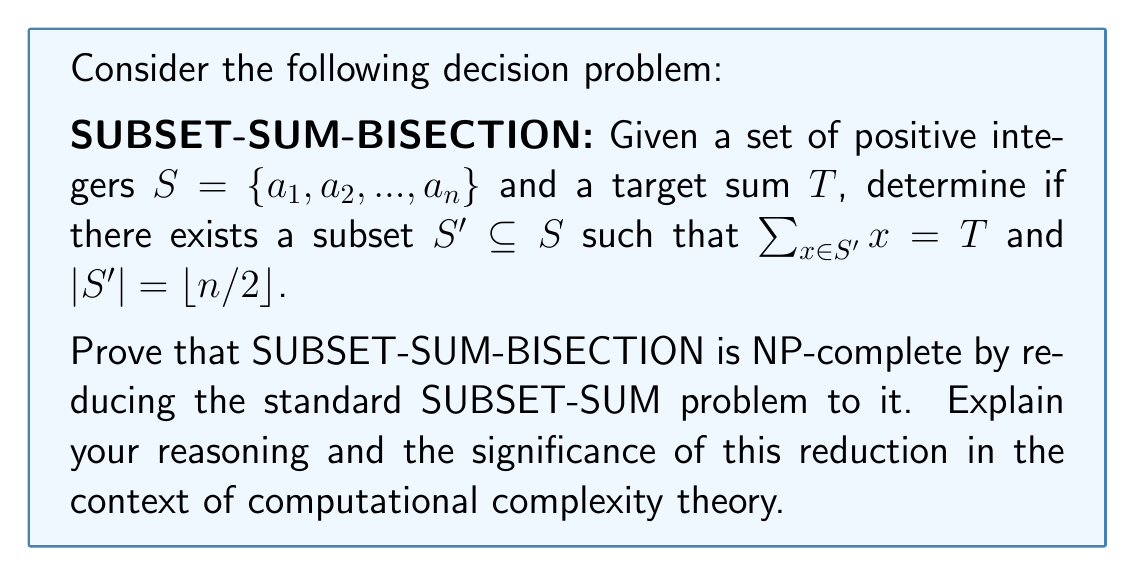Give your solution to this math problem. To prove that SUBSET-SUM-BISECTION is NP-complete, we need to show two things:
1. It is in NP
2. It is NP-hard (by reducing a known NP-complete problem to it)

Step 1: Showing SUBSET-SUM-BISECTION is in NP
This is straightforward. Given a solution (a subset $S'$), we can verify in polynomial time that:
a) $|S'| = \lfloor n/2 \rfloor$
b) $\sum_{x \in S'} x = T$

Step 2: Reducing SUBSET-SUM to SUBSET-SUM-BISECTION
We know SUBSET-SUM is NP-complete. Let's reduce it to SUBSET-SUM-BISECTION.

Given a SUBSET-SUM instance $(S, T)$, where $S = \{a_1, ..., a_n\}$ and $T$ is the target sum, we construct a SUBSET-SUM-BISECTION instance $(S', T')$ as follows:

1. If $n$ is odd, add a 0 to $S$ to make it even.
2. Let $M = 1 + \sum_{i=1}^n a_i$
3. $S' = S \cup \{M, M, ..., M\}$ (add $n$ copies of $M$)
4. $T' = T + nM/2$

This reduction is polynomial-time computable.

Claim: The original SUBSET-SUM instance has a solution if and only if the new SUBSET-SUM-BISECTION instance has a solution.

Proof:
($\Rightarrow$) If SUBSET-SUM has a solution, let $k$ be the size of this solution. Choose $k$ elements from the original set and $n-k$ copies of $M$ from the added elements. This subset has size $n = |S'|/2$ and sum $T + (n-k)M = T'$.

($\Leftarrow$) If SUBSET-SUM-BISECTION has a solution, it must include exactly $n/2$ elements. Due to the choice of $M$, it's impossible to reach $T'$ without using exactly $n/2$ copies of $M$. The remaining elements must sum to $T$, forming a solution to the original SUBSET-SUM problem.

This reduction demonstrates that SUBSET-SUM-BISECTION is at least as hard as SUBSET-SUM. Since SUBSET-SUM is NP-complete, this proves that SUBSET-SUM-BISECTION is NP-hard.

Combining steps 1 and 2, we conclude that SUBSET-SUM-BISECTION is NP-complete.

The significance of this reduction lies in its demonstration of how we can use known NP-complete problems to prove the NP-completeness of new problems. This technique, known as reduction, is fundamental in computational complexity theory. It allows us to establish relationships between problems and build a hierarchy of computational difficulty. By showing that a problem is at least as hard as a known NP-complete problem, we prove its NP-hardness, which is a crucial step in establishing NP-completeness.
Answer: SUBSET-SUM-BISECTION is NP-complete. The proof involves showing it is in NP and reducing the known NP-complete problem SUBSET-SUM to it. The reduction transforms a SUBSET-SUM instance $(S, T)$ to a SUBSET-SUM-BISECTION instance $(S', T')$ by adding $n$ copies of a large number $M$ to $S$ and adjusting the target sum accordingly. This reduction preserves the solution property and is computable in polynomial time, thereby establishing the NP-completeness of SUBSET-SUM-BISECTION. 